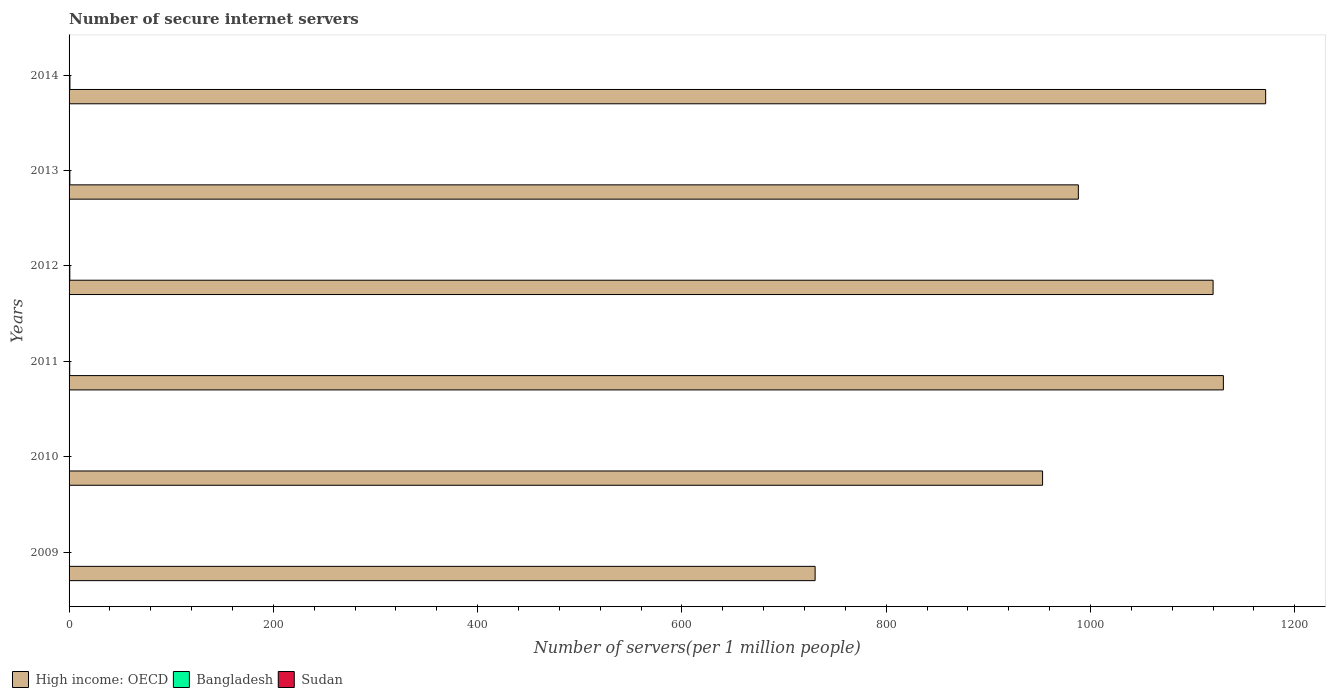Are the number of bars per tick equal to the number of legend labels?
Your answer should be compact. Yes. Are the number of bars on each tick of the Y-axis equal?
Your response must be concise. Yes. What is the label of the 5th group of bars from the top?
Offer a terse response. 2010. In how many cases, is the number of bars for a given year not equal to the number of legend labels?
Provide a succinct answer. 0. What is the number of secure internet servers in Bangladesh in 2010?
Offer a terse response. 0.31. Across all years, what is the maximum number of secure internet servers in Sudan?
Your answer should be very brief. 0.06. Across all years, what is the minimum number of secure internet servers in Bangladesh?
Provide a succinct answer. 0.19. In which year was the number of secure internet servers in High income: OECD minimum?
Provide a succinct answer. 2009. What is the total number of secure internet servers in Bangladesh in the graph?
Keep it short and to the point. 3.48. What is the difference between the number of secure internet servers in High income: OECD in 2009 and that in 2011?
Provide a succinct answer. -399.69. What is the difference between the number of secure internet servers in High income: OECD in 2011 and the number of secure internet servers in Bangladesh in 2012?
Your response must be concise. 1129.37. What is the average number of secure internet servers in Bangladesh per year?
Your answer should be compact. 0.58. In the year 2013, what is the difference between the number of secure internet servers in Bangladesh and number of secure internet servers in Sudan?
Provide a short and direct response. 0.72. What is the ratio of the number of secure internet servers in Sudan in 2011 to that in 2014?
Your response must be concise. 0.83. What is the difference between the highest and the second highest number of secure internet servers in Sudan?
Offer a terse response. 0.02. What is the difference between the highest and the lowest number of secure internet servers in High income: OECD?
Keep it short and to the point. 441.09. In how many years, is the number of secure internet servers in High income: OECD greater than the average number of secure internet servers in High income: OECD taken over all years?
Your answer should be very brief. 3. Is the sum of the number of secure internet servers in High income: OECD in 2010 and 2011 greater than the maximum number of secure internet servers in Sudan across all years?
Make the answer very short. Yes. Is it the case that in every year, the sum of the number of secure internet servers in High income: OECD and number of secure internet servers in Sudan is greater than the number of secure internet servers in Bangladesh?
Keep it short and to the point. Yes. How many years are there in the graph?
Make the answer very short. 6. What is the difference between two consecutive major ticks on the X-axis?
Your response must be concise. 200. Are the values on the major ticks of X-axis written in scientific E-notation?
Your answer should be compact. No. Does the graph contain any zero values?
Offer a terse response. No. Where does the legend appear in the graph?
Provide a succinct answer. Bottom left. How many legend labels are there?
Offer a terse response. 3. How are the legend labels stacked?
Keep it short and to the point. Horizontal. What is the title of the graph?
Ensure brevity in your answer.  Number of secure internet servers. Does "Sub-Saharan Africa (all income levels)" appear as one of the legend labels in the graph?
Provide a succinct answer. No. What is the label or title of the X-axis?
Keep it short and to the point. Number of servers(per 1 million people). What is the Number of servers(per 1 million people) in High income: OECD in 2009?
Offer a very short reply. 730.41. What is the Number of servers(per 1 million people) in Bangladesh in 2009?
Your answer should be very brief. 0.19. What is the Number of servers(per 1 million people) of Sudan in 2009?
Give a very brief answer. 0.02. What is the Number of servers(per 1 million people) of High income: OECD in 2010?
Your response must be concise. 953.1. What is the Number of servers(per 1 million people) of Bangladesh in 2010?
Provide a succinct answer. 0.31. What is the Number of servers(per 1 million people) of Sudan in 2010?
Your answer should be very brief. 0.02. What is the Number of servers(per 1 million people) in High income: OECD in 2011?
Your answer should be compact. 1130.1. What is the Number of servers(per 1 million people) in Bangladesh in 2011?
Keep it short and to the point. 0.63. What is the Number of servers(per 1 million people) in Sudan in 2011?
Ensure brevity in your answer.  0.02. What is the Number of servers(per 1 million people) of High income: OECD in 2012?
Give a very brief answer. 1120.04. What is the Number of servers(per 1 million people) of Bangladesh in 2012?
Your answer should be compact. 0.73. What is the Number of servers(per 1 million people) of Sudan in 2012?
Your answer should be compact. 0.06. What is the Number of servers(per 1 million people) of High income: OECD in 2013?
Offer a terse response. 988.12. What is the Number of servers(per 1 million people) in Bangladesh in 2013?
Ensure brevity in your answer.  0.76. What is the Number of servers(per 1 million people) of Sudan in 2013?
Ensure brevity in your answer.  0.04. What is the Number of servers(per 1 million people) of High income: OECD in 2014?
Give a very brief answer. 1171.51. What is the Number of servers(per 1 million people) of Bangladesh in 2014?
Your answer should be very brief. 0.85. What is the Number of servers(per 1 million people) in Sudan in 2014?
Give a very brief answer. 0.03. Across all years, what is the maximum Number of servers(per 1 million people) in High income: OECD?
Give a very brief answer. 1171.51. Across all years, what is the maximum Number of servers(per 1 million people) in Bangladesh?
Keep it short and to the point. 0.85. Across all years, what is the maximum Number of servers(per 1 million people) of Sudan?
Provide a succinct answer. 0.06. Across all years, what is the minimum Number of servers(per 1 million people) of High income: OECD?
Provide a succinct answer. 730.41. Across all years, what is the minimum Number of servers(per 1 million people) in Bangladesh?
Your answer should be very brief. 0.19. Across all years, what is the minimum Number of servers(per 1 million people) of Sudan?
Your answer should be compact. 0.02. What is the total Number of servers(per 1 million people) in High income: OECD in the graph?
Offer a very short reply. 6093.29. What is the total Number of servers(per 1 million people) in Bangladesh in the graph?
Provide a succinct answer. 3.48. What is the total Number of servers(per 1 million people) in Sudan in the graph?
Provide a short and direct response. 0.19. What is the difference between the Number of servers(per 1 million people) of High income: OECD in 2009 and that in 2010?
Give a very brief answer. -222.69. What is the difference between the Number of servers(per 1 million people) in Bangladesh in 2009 and that in 2010?
Make the answer very short. -0.12. What is the difference between the Number of servers(per 1 million people) of Sudan in 2009 and that in 2010?
Your answer should be compact. 0. What is the difference between the Number of servers(per 1 million people) of High income: OECD in 2009 and that in 2011?
Offer a very short reply. -399.69. What is the difference between the Number of servers(per 1 million people) in Bangladesh in 2009 and that in 2011?
Your answer should be very brief. -0.43. What is the difference between the Number of servers(per 1 million people) of Sudan in 2009 and that in 2011?
Provide a succinct answer. 0. What is the difference between the Number of servers(per 1 million people) of High income: OECD in 2009 and that in 2012?
Keep it short and to the point. -389.63. What is the difference between the Number of servers(per 1 million people) in Bangladesh in 2009 and that in 2012?
Offer a terse response. -0.53. What is the difference between the Number of servers(per 1 million people) of Sudan in 2009 and that in 2012?
Offer a very short reply. -0.04. What is the difference between the Number of servers(per 1 million people) in High income: OECD in 2009 and that in 2013?
Your answer should be very brief. -257.71. What is the difference between the Number of servers(per 1 million people) of Bangladesh in 2009 and that in 2013?
Ensure brevity in your answer.  -0.57. What is the difference between the Number of servers(per 1 million people) of Sudan in 2009 and that in 2013?
Offer a very short reply. -0.02. What is the difference between the Number of servers(per 1 million people) in High income: OECD in 2009 and that in 2014?
Keep it short and to the point. -441.09. What is the difference between the Number of servers(per 1 million people) of Bangladesh in 2009 and that in 2014?
Make the answer very short. -0.66. What is the difference between the Number of servers(per 1 million people) in Sudan in 2009 and that in 2014?
Your answer should be very brief. -0. What is the difference between the Number of servers(per 1 million people) of High income: OECD in 2010 and that in 2011?
Provide a succinct answer. -177. What is the difference between the Number of servers(per 1 million people) of Bangladesh in 2010 and that in 2011?
Ensure brevity in your answer.  -0.32. What is the difference between the Number of servers(per 1 million people) in Sudan in 2010 and that in 2011?
Keep it short and to the point. 0. What is the difference between the Number of servers(per 1 million people) of High income: OECD in 2010 and that in 2012?
Ensure brevity in your answer.  -166.94. What is the difference between the Number of servers(per 1 million people) of Bangladesh in 2010 and that in 2012?
Give a very brief answer. -0.42. What is the difference between the Number of servers(per 1 million people) of Sudan in 2010 and that in 2012?
Ensure brevity in your answer.  -0.04. What is the difference between the Number of servers(per 1 million people) of High income: OECD in 2010 and that in 2013?
Provide a succinct answer. -35.02. What is the difference between the Number of servers(per 1 million people) of Bangladesh in 2010 and that in 2013?
Your response must be concise. -0.45. What is the difference between the Number of servers(per 1 million people) of Sudan in 2010 and that in 2013?
Offer a terse response. -0.02. What is the difference between the Number of servers(per 1 million people) in High income: OECD in 2010 and that in 2014?
Your answer should be compact. -218.41. What is the difference between the Number of servers(per 1 million people) in Bangladesh in 2010 and that in 2014?
Keep it short and to the point. -0.54. What is the difference between the Number of servers(per 1 million people) in Sudan in 2010 and that in 2014?
Your answer should be compact. -0. What is the difference between the Number of servers(per 1 million people) of High income: OECD in 2011 and that in 2012?
Your answer should be compact. 10.06. What is the difference between the Number of servers(per 1 million people) of Bangladesh in 2011 and that in 2012?
Give a very brief answer. -0.1. What is the difference between the Number of servers(per 1 million people) of Sudan in 2011 and that in 2012?
Offer a very short reply. -0.04. What is the difference between the Number of servers(per 1 million people) of High income: OECD in 2011 and that in 2013?
Your answer should be compact. 141.98. What is the difference between the Number of servers(per 1 million people) in Bangladesh in 2011 and that in 2013?
Provide a short and direct response. -0.14. What is the difference between the Number of servers(per 1 million people) of Sudan in 2011 and that in 2013?
Offer a very short reply. -0.02. What is the difference between the Number of servers(per 1 million people) of High income: OECD in 2011 and that in 2014?
Your answer should be compact. -41.41. What is the difference between the Number of servers(per 1 million people) of Bangladesh in 2011 and that in 2014?
Offer a very short reply. -0.23. What is the difference between the Number of servers(per 1 million people) of Sudan in 2011 and that in 2014?
Offer a very short reply. -0. What is the difference between the Number of servers(per 1 million people) in High income: OECD in 2012 and that in 2013?
Offer a very short reply. 131.92. What is the difference between the Number of servers(per 1 million people) of Bangladesh in 2012 and that in 2013?
Provide a succinct answer. -0.04. What is the difference between the Number of servers(per 1 million people) of Sudan in 2012 and that in 2013?
Ensure brevity in your answer.  0.02. What is the difference between the Number of servers(per 1 million people) of High income: OECD in 2012 and that in 2014?
Make the answer very short. -51.47. What is the difference between the Number of servers(per 1 million people) in Bangladesh in 2012 and that in 2014?
Provide a succinct answer. -0.13. What is the difference between the Number of servers(per 1 million people) in Sudan in 2012 and that in 2014?
Provide a succinct answer. 0.04. What is the difference between the Number of servers(per 1 million people) in High income: OECD in 2013 and that in 2014?
Give a very brief answer. -183.39. What is the difference between the Number of servers(per 1 million people) of Bangladesh in 2013 and that in 2014?
Provide a short and direct response. -0.09. What is the difference between the Number of servers(per 1 million people) in Sudan in 2013 and that in 2014?
Give a very brief answer. 0.01. What is the difference between the Number of servers(per 1 million people) of High income: OECD in 2009 and the Number of servers(per 1 million people) of Bangladesh in 2010?
Your answer should be very brief. 730.1. What is the difference between the Number of servers(per 1 million people) of High income: OECD in 2009 and the Number of servers(per 1 million people) of Sudan in 2010?
Give a very brief answer. 730.39. What is the difference between the Number of servers(per 1 million people) in Bangladesh in 2009 and the Number of servers(per 1 million people) in Sudan in 2010?
Provide a succinct answer. 0.17. What is the difference between the Number of servers(per 1 million people) in High income: OECD in 2009 and the Number of servers(per 1 million people) in Bangladesh in 2011?
Your answer should be compact. 729.79. What is the difference between the Number of servers(per 1 million people) in High income: OECD in 2009 and the Number of servers(per 1 million people) in Sudan in 2011?
Keep it short and to the point. 730.39. What is the difference between the Number of servers(per 1 million people) of Bangladesh in 2009 and the Number of servers(per 1 million people) of Sudan in 2011?
Keep it short and to the point. 0.17. What is the difference between the Number of servers(per 1 million people) of High income: OECD in 2009 and the Number of servers(per 1 million people) of Bangladesh in 2012?
Your answer should be very brief. 729.69. What is the difference between the Number of servers(per 1 million people) of High income: OECD in 2009 and the Number of servers(per 1 million people) of Sudan in 2012?
Keep it short and to the point. 730.35. What is the difference between the Number of servers(per 1 million people) in Bangladesh in 2009 and the Number of servers(per 1 million people) in Sudan in 2012?
Offer a terse response. 0.13. What is the difference between the Number of servers(per 1 million people) of High income: OECD in 2009 and the Number of servers(per 1 million people) of Bangladesh in 2013?
Give a very brief answer. 729.65. What is the difference between the Number of servers(per 1 million people) of High income: OECD in 2009 and the Number of servers(per 1 million people) of Sudan in 2013?
Give a very brief answer. 730.37. What is the difference between the Number of servers(per 1 million people) of Bangladesh in 2009 and the Number of servers(per 1 million people) of Sudan in 2013?
Offer a terse response. 0.15. What is the difference between the Number of servers(per 1 million people) of High income: OECD in 2009 and the Number of servers(per 1 million people) of Bangladesh in 2014?
Give a very brief answer. 729.56. What is the difference between the Number of servers(per 1 million people) in High income: OECD in 2009 and the Number of servers(per 1 million people) in Sudan in 2014?
Your answer should be compact. 730.39. What is the difference between the Number of servers(per 1 million people) in Bangladesh in 2009 and the Number of servers(per 1 million people) in Sudan in 2014?
Keep it short and to the point. 0.17. What is the difference between the Number of servers(per 1 million people) of High income: OECD in 2010 and the Number of servers(per 1 million people) of Bangladesh in 2011?
Ensure brevity in your answer.  952.48. What is the difference between the Number of servers(per 1 million people) of High income: OECD in 2010 and the Number of servers(per 1 million people) of Sudan in 2011?
Your response must be concise. 953.08. What is the difference between the Number of servers(per 1 million people) in Bangladesh in 2010 and the Number of servers(per 1 million people) in Sudan in 2011?
Offer a very short reply. 0.29. What is the difference between the Number of servers(per 1 million people) of High income: OECD in 2010 and the Number of servers(per 1 million people) of Bangladesh in 2012?
Give a very brief answer. 952.37. What is the difference between the Number of servers(per 1 million people) in High income: OECD in 2010 and the Number of servers(per 1 million people) in Sudan in 2012?
Ensure brevity in your answer.  953.04. What is the difference between the Number of servers(per 1 million people) in Bangladesh in 2010 and the Number of servers(per 1 million people) in Sudan in 2012?
Your answer should be very brief. 0.25. What is the difference between the Number of servers(per 1 million people) of High income: OECD in 2010 and the Number of servers(per 1 million people) of Bangladesh in 2013?
Provide a short and direct response. 952.34. What is the difference between the Number of servers(per 1 million people) in High income: OECD in 2010 and the Number of servers(per 1 million people) in Sudan in 2013?
Ensure brevity in your answer.  953.06. What is the difference between the Number of servers(per 1 million people) in Bangladesh in 2010 and the Number of servers(per 1 million people) in Sudan in 2013?
Give a very brief answer. 0.27. What is the difference between the Number of servers(per 1 million people) in High income: OECD in 2010 and the Number of servers(per 1 million people) in Bangladesh in 2014?
Your answer should be very brief. 952.25. What is the difference between the Number of servers(per 1 million people) in High income: OECD in 2010 and the Number of servers(per 1 million people) in Sudan in 2014?
Make the answer very short. 953.08. What is the difference between the Number of servers(per 1 million people) of Bangladesh in 2010 and the Number of servers(per 1 million people) of Sudan in 2014?
Make the answer very short. 0.28. What is the difference between the Number of servers(per 1 million people) in High income: OECD in 2011 and the Number of servers(per 1 million people) in Bangladesh in 2012?
Provide a short and direct response. 1129.37. What is the difference between the Number of servers(per 1 million people) of High income: OECD in 2011 and the Number of servers(per 1 million people) of Sudan in 2012?
Your answer should be very brief. 1130.04. What is the difference between the Number of servers(per 1 million people) in Bangladesh in 2011 and the Number of servers(per 1 million people) in Sudan in 2012?
Your answer should be very brief. 0.56. What is the difference between the Number of servers(per 1 million people) in High income: OECD in 2011 and the Number of servers(per 1 million people) in Bangladesh in 2013?
Offer a very short reply. 1129.34. What is the difference between the Number of servers(per 1 million people) of High income: OECD in 2011 and the Number of servers(per 1 million people) of Sudan in 2013?
Offer a very short reply. 1130.06. What is the difference between the Number of servers(per 1 million people) in Bangladesh in 2011 and the Number of servers(per 1 million people) in Sudan in 2013?
Provide a succinct answer. 0.59. What is the difference between the Number of servers(per 1 million people) of High income: OECD in 2011 and the Number of servers(per 1 million people) of Bangladesh in 2014?
Provide a succinct answer. 1129.25. What is the difference between the Number of servers(per 1 million people) in High income: OECD in 2011 and the Number of servers(per 1 million people) in Sudan in 2014?
Offer a terse response. 1130.07. What is the difference between the Number of servers(per 1 million people) of Bangladesh in 2011 and the Number of servers(per 1 million people) of Sudan in 2014?
Ensure brevity in your answer.  0.6. What is the difference between the Number of servers(per 1 million people) in High income: OECD in 2012 and the Number of servers(per 1 million people) in Bangladesh in 2013?
Offer a very short reply. 1119.28. What is the difference between the Number of servers(per 1 million people) of High income: OECD in 2012 and the Number of servers(per 1 million people) of Sudan in 2013?
Give a very brief answer. 1120. What is the difference between the Number of servers(per 1 million people) of Bangladesh in 2012 and the Number of servers(per 1 million people) of Sudan in 2013?
Offer a terse response. 0.69. What is the difference between the Number of servers(per 1 million people) in High income: OECD in 2012 and the Number of servers(per 1 million people) in Bangladesh in 2014?
Offer a very short reply. 1119.19. What is the difference between the Number of servers(per 1 million people) of High income: OECD in 2012 and the Number of servers(per 1 million people) of Sudan in 2014?
Your response must be concise. 1120.02. What is the difference between the Number of servers(per 1 million people) of Bangladesh in 2012 and the Number of servers(per 1 million people) of Sudan in 2014?
Provide a succinct answer. 0.7. What is the difference between the Number of servers(per 1 million people) of High income: OECD in 2013 and the Number of servers(per 1 million people) of Bangladesh in 2014?
Ensure brevity in your answer.  987.27. What is the difference between the Number of servers(per 1 million people) of High income: OECD in 2013 and the Number of servers(per 1 million people) of Sudan in 2014?
Offer a terse response. 988.1. What is the difference between the Number of servers(per 1 million people) in Bangladesh in 2013 and the Number of servers(per 1 million people) in Sudan in 2014?
Offer a terse response. 0.74. What is the average Number of servers(per 1 million people) in High income: OECD per year?
Provide a succinct answer. 1015.55. What is the average Number of servers(per 1 million people) of Bangladesh per year?
Ensure brevity in your answer.  0.58. What is the average Number of servers(per 1 million people) in Sudan per year?
Ensure brevity in your answer.  0.03. In the year 2009, what is the difference between the Number of servers(per 1 million people) in High income: OECD and Number of servers(per 1 million people) in Bangladesh?
Your answer should be compact. 730.22. In the year 2009, what is the difference between the Number of servers(per 1 million people) in High income: OECD and Number of servers(per 1 million people) in Sudan?
Offer a very short reply. 730.39. In the year 2009, what is the difference between the Number of servers(per 1 million people) of Bangladesh and Number of servers(per 1 million people) of Sudan?
Your response must be concise. 0.17. In the year 2010, what is the difference between the Number of servers(per 1 million people) in High income: OECD and Number of servers(per 1 million people) in Bangladesh?
Give a very brief answer. 952.79. In the year 2010, what is the difference between the Number of servers(per 1 million people) of High income: OECD and Number of servers(per 1 million people) of Sudan?
Your response must be concise. 953.08. In the year 2010, what is the difference between the Number of servers(per 1 million people) in Bangladesh and Number of servers(per 1 million people) in Sudan?
Offer a terse response. 0.29. In the year 2011, what is the difference between the Number of servers(per 1 million people) in High income: OECD and Number of servers(per 1 million people) in Bangladesh?
Offer a terse response. 1129.47. In the year 2011, what is the difference between the Number of servers(per 1 million people) of High income: OECD and Number of servers(per 1 million people) of Sudan?
Keep it short and to the point. 1130.08. In the year 2011, what is the difference between the Number of servers(per 1 million people) of Bangladesh and Number of servers(per 1 million people) of Sudan?
Ensure brevity in your answer.  0.6. In the year 2012, what is the difference between the Number of servers(per 1 million people) of High income: OECD and Number of servers(per 1 million people) of Bangladesh?
Provide a succinct answer. 1119.31. In the year 2012, what is the difference between the Number of servers(per 1 million people) in High income: OECD and Number of servers(per 1 million people) in Sudan?
Your answer should be compact. 1119.98. In the year 2012, what is the difference between the Number of servers(per 1 million people) of Bangladesh and Number of servers(per 1 million people) of Sudan?
Give a very brief answer. 0.67. In the year 2013, what is the difference between the Number of servers(per 1 million people) in High income: OECD and Number of servers(per 1 million people) in Bangladesh?
Give a very brief answer. 987.36. In the year 2013, what is the difference between the Number of servers(per 1 million people) of High income: OECD and Number of servers(per 1 million people) of Sudan?
Your answer should be very brief. 988.08. In the year 2013, what is the difference between the Number of servers(per 1 million people) in Bangladesh and Number of servers(per 1 million people) in Sudan?
Give a very brief answer. 0.72. In the year 2014, what is the difference between the Number of servers(per 1 million people) of High income: OECD and Number of servers(per 1 million people) of Bangladesh?
Offer a terse response. 1170.65. In the year 2014, what is the difference between the Number of servers(per 1 million people) in High income: OECD and Number of servers(per 1 million people) in Sudan?
Ensure brevity in your answer.  1171.48. In the year 2014, what is the difference between the Number of servers(per 1 million people) in Bangladesh and Number of servers(per 1 million people) in Sudan?
Keep it short and to the point. 0.83. What is the ratio of the Number of servers(per 1 million people) in High income: OECD in 2009 to that in 2010?
Your response must be concise. 0.77. What is the ratio of the Number of servers(per 1 million people) in Bangladesh in 2009 to that in 2010?
Give a very brief answer. 0.62. What is the ratio of the Number of servers(per 1 million people) in Sudan in 2009 to that in 2010?
Your answer should be compact. 1.03. What is the ratio of the Number of servers(per 1 million people) of High income: OECD in 2009 to that in 2011?
Keep it short and to the point. 0.65. What is the ratio of the Number of servers(per 1 million people) in Bangladesh in 2009 to that in 2011?
Your answer should be very brief. 0.31. What is the ratio of the Number of servers(per 1 million people) in Sudan in 2009 to that in 2011?
Ensure brevity in your answer.  1.06. What is the ratio of the Number of servers(per 1 million people) in High income: OECD in 2009 to that in 2012?
Give a very brief answer. 0.65. What is the ratio of the Number of servers(per 1 million people) in Bangladesh in 2009 to that in 2012?
Provide a succinct answer. 0.27. What is the ratio of the Number of servers(per 1 million people) of Sudan in 2009 to that in 2012?
Your response must be concise. 0.36. What is the ratio of the Number of servers(per 1 million people) of High income: OECD in 2009 to that in 2013?
Your response must be concise. 0.74. What is the ratio of the Number of servers(per 1 million people) in Bangladesh in 2009 to that in 2013?
Your response must be concise. 0.25. What is the ratio of the Number of servers(per 1 million people) in Sudan in 2009 to that in 2013?
Keep it short and to the point. 0.56. What is the ratio of the Number of servers(per 1 million people) of High income: OECD in 2009 to that in 2014?
Provide a short and direct response. 0.62. What is the ratio of the Number of servers(per 1 million people) in Bangladesh in 2009 to that in 2014?
Your answer should be compact. 0.23. What is the ratio of the Number of servers(per 1 million people) in Sudan in 2009 to that in 2014?
Offer a terse response. 0.88. What is the ratio of the Number of servers(per 1 million people) of High income: OECD in 2010 to that in 2011?
Keep it short and to the point. 0.84. What is the ratio of the Number of servers(per 1 million people) in Bangladesh in 2010 to that in 2011?
Provide a succinct answer. 0.5. What is the ratio of the Number of servers(per 1 million people) of Sudan in 2010 to that in 2011?
Provide a succinct answer. 1.03. What is the ratio of the Number of servers(per 1 million people) of High income: OECD in 2010 to that in 2012?
Your answer should be very brief. 0.85. What is the ratio of the Number of servers(per 1 million people) of Bangladesh in 2010 to that in 2012?
Your answer should be compact. 0.43. What is the ratio of the Number of servers(per 1 million people) of Sudan in 2010 to that in 2012?
Offer a very short reply. 0.35. What is the ratio of the Number of servers(per 1 million people) of High income: OECD in 2010 to that in 2013?
Your answer should be compact. 0.96. What is the ratio of the Number of servers(per 1 million people) of Bangladesh in 2010 to that in 2013?
Offer a very short reply. 0.41. What is the ratio of the Number of servers(per 1 million people) in Sudan in 2010 to that in 2013?
Your response must be concise. 0.54. What is the ratio of the Number of servers(per 1 million people) in High income: OECD in 2010 to that in 2014?
Ensure brevity in your answer.  0.81. What is the ratio of the Number of servers(per 1 million people) of Bangladesh in 2010 to that in 2014?
Your response must be concise. 0.36. What is the ratio of the Number of servers(per 1 million people) of Sudan in 2010 to that in 2014?
Make the answer very short. 0.85. What is the ratio of the Number of servers(per 1 million people) in Bangladesh in 2011 to that in 2012?
Offer a very short reply. 0.86. What is the ratio of the Number of servers(per 1 million people) of Sudan in 2011 to that in 2012?
Give a very brief answer. 0.34. What is the ratio of the Number of servers(per 1 million people) of High income: OECD in 2011 to that in 2013?
Your answer should be very brief. 1.14. What is the ratio of the Number of servers(per 1 million people) of Bangladesh in 2011 to that in 2013?
Keep it short and to the point. 0.82. What is the ratio of the Number of servers(per 1 million people) of Sudan in 2011 to that in 2013?
Provide a succinct answer. 0.53. What is the ratio of the Number of servers(per 1 million people) in High income: OECD in 2011 to that in 2014?
Your answer should be very brief. 0.96. What is the ratio of the Number of servers(per 1 million people) of Bangladesh in 2011 to that in 2014?
Your response must be concise. 0.73. What is the ratio of the Number of servers(per 1 million people) in Sudan in 2011 to that in 2014?
Your answer should be very brief. 0.83. What is the ratio of the Number of servers(per 1 million people) in High income: OECD in 2012 to that in 2013?
Offer a very short reply. 1.13. What is the ratio of the Number of servers(per 1 million people) of Bangladesh in 2012 to that in 2013?
Offer a very short reply. 0.95. What is the ratio of the Number of servers(per 1 million people) in Sudan in 2012 to that in 2013?
Your answer should be compact. 1.54. What is the ratio of the Number of servers(per 1 million people) in High income: OECD in 2012 to that in 2014?
Provide a short and direct response. 0.96. What is the ratio of the Number of servers(per 1 million people) of Bangladesh in 2012 to that in 2014?
Your answer should be compact. 0.85. What is the ratio of the Number of servers(per 1 million people) of Sudan in 2012 to that in 2014?
Your answer should be compact. 2.42. What is the ratio of the Number of servers(per 1 million people) of High income: OECD in 2013 to that in 2014?
Offer a very short reply. 0.84. What is the ratio of the Number of servers(per 1 million people) of Bangladesh in 2013 to that in 2014?
Your answer should be very brief. 0.89. What is the ratio of the Number of servers(per 1 million people) of Sudan in 2013 to that in 2014?
Make the answer very short. 1.57. What is the difference between the highest and the second highest Number of servers(per 1 million people) in High income: OECD?
Your response must be concise. 41.41. What is the difference between the highest and the second highest Number of servers(per 1 million people) in Bangladesh?
Your answer should be very brief. 0.09. What is the difference between the highest and the second highest Number of servers(per 1 million people) of Sudan?
Make the answer very short. 0.02. What is the difference between the highest and the lowest Number of servers(per 1 million people) of High income: OECD?
Your response must be concise. 441.09. What is the difference between the highest and the lowest Number of servers(per 1 million people) of Bangladesh?
Give a very brief answer. 0.66. What is the difference between the highest and the lowest Number of servers(per 1 million people) of Sudan?
Your answer should be compact. 0.04. 